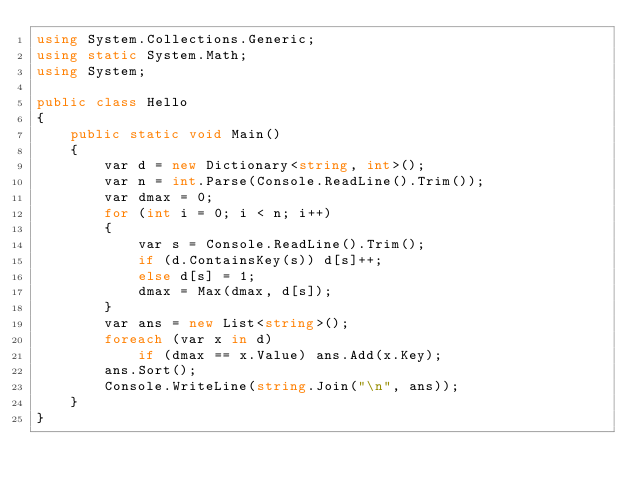Convert code to text. <code><loc_0><loc_0><loc_500><loc_500><_C#_>using System.Collections.Generic;
using static System.Math;
using System;

public class Hello
{
    public static void Main()
    {
        var d = new Dictionary<string, int>();
        var n = int.Parse(Console.ReadLine().Trim());
        var dmax = 0;
        for (int i = 0; i < n; i++)
        {
            var s = Console.ReadLine().Trim();
            if (d.ContainsKey(s)) d[s]++;
            else d[s] = 1;
            dmax = Max(dmax, d[s]);
        }
        var ans = new List<string>();
        foreach (var x in d)
            if (dmax == x.Value) ans.Add(x.Key);
        ans.Sort();
        Console.WriteLine(string.Join("\n", ans));
    }
}
</code> 